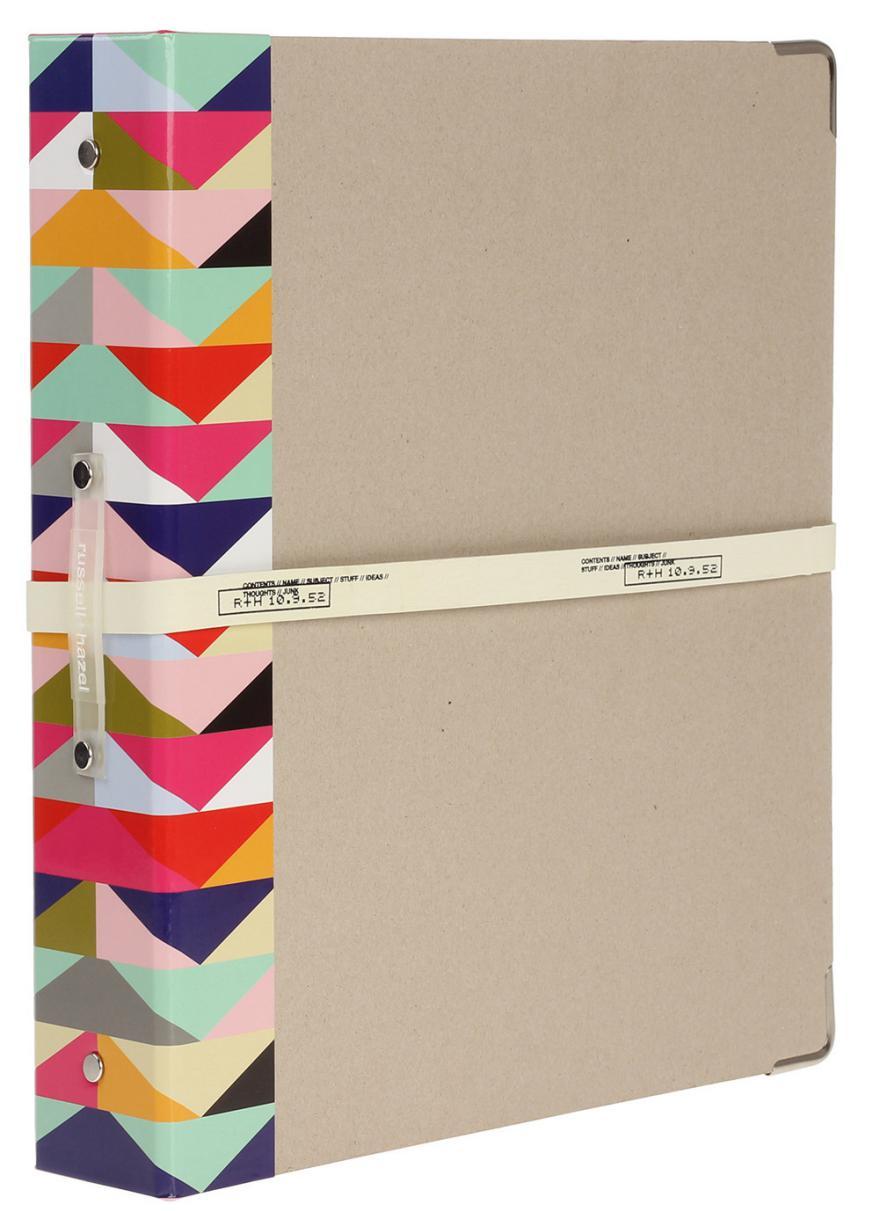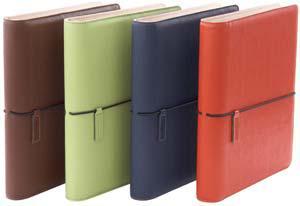The first image is the image on the left, the second image is the image on the right. Given the left and right images, does the statement "There are at least three binders." hold true? Answer yes or no. Yes. The first image is the image on the left, the second image is the image on the right. Assess this claim about the two images: "One of the binders is solid blue.". Correct or not? Answer yes or no. Yes. 